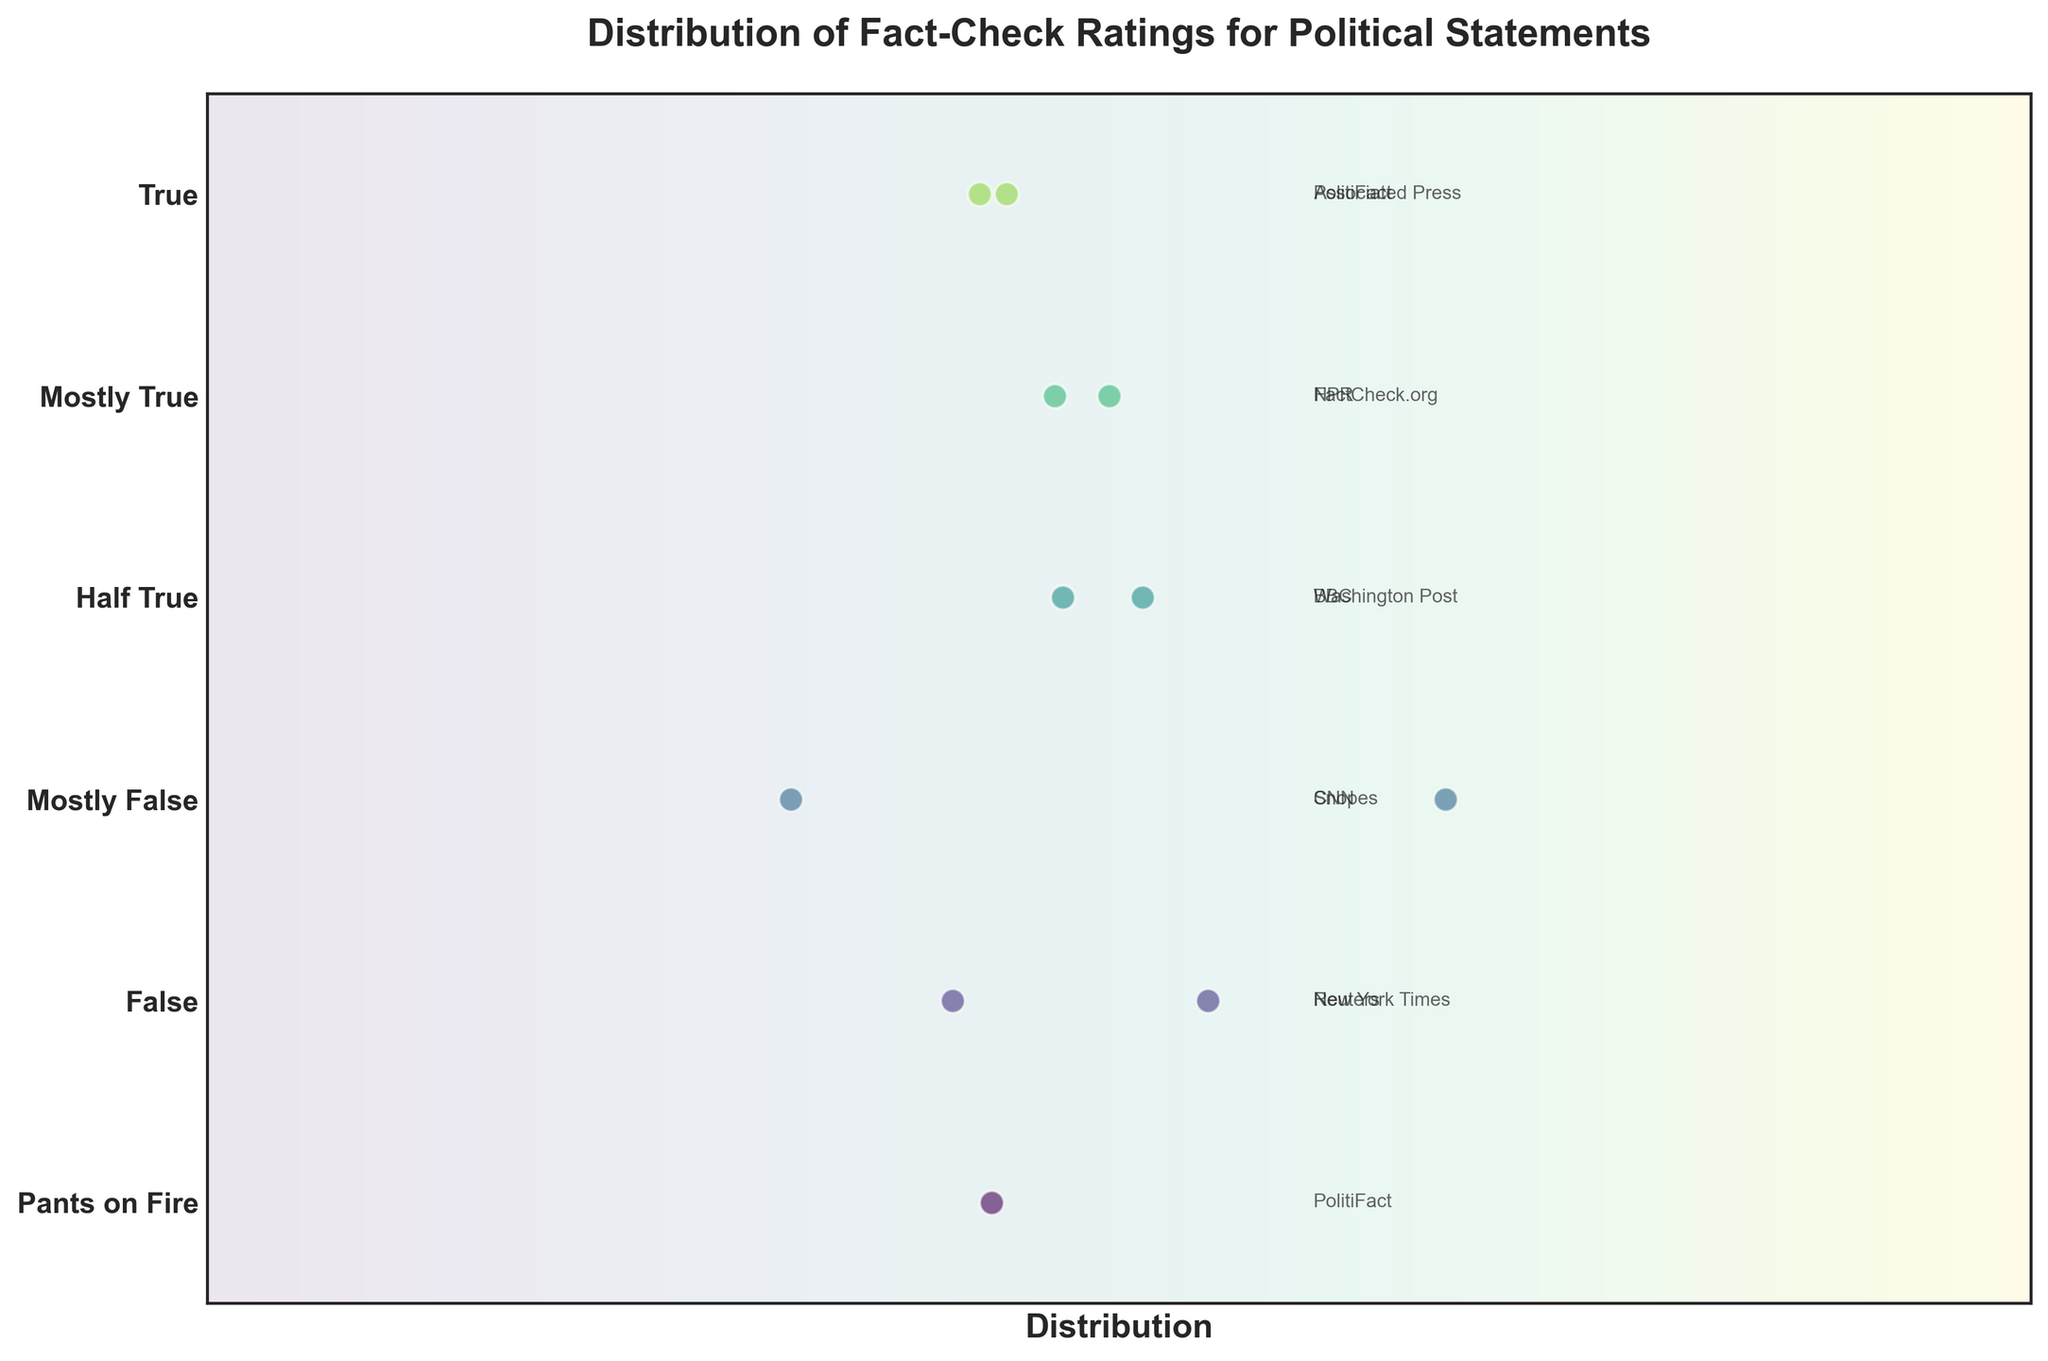What's the title of the figure? The title is usually found at the top of the figure. In this case, it reads "Distribution of Fact-Check Ratings for Political Statements".
Answer: Distribution of Fact-Check Ratings for Political Statements How many statements were rated as 'True'? Look at the strip plot for the 'True' rating and count the dots. The 'True' rating has two dots representing two statements.
Answer: 2 Which rating has the most data points? Count the number of dots in each rating category. The 'Half True' and 'Mostly True' sections have the same number, which is two. However, all ratings have either one or two points, so no single rating overwhelmingly has the most.
Answer: Half True, Mostly True What is the color gradient used for the background? The gradient starts light and transitions to a darker color vertically, representing a spectrum found in the 'viridis' color map used for visibility.
Answer: Viridis How many sources are represented in the data? Each unique source label in the figure corresponds to a different source. Counting these unique labels gives us the number of sources. There are 11 unique source labels: PolitiFact, FactCheck.org, Washington Post, Snopes, Reuters, Associated Press, NPR, BBC, CNN, New York Times.
Answer: 11 Which source made the statement rated 'Pants on Fire'? Look at the 'Pants on Fire' strip and identify the source label next to the dot. The source for the 'Pants on Fire' statement is PolitiFact.
Answer: PolitiFact Which statement was rated 'Mostly False'? Read the annotation next to the dot in the 'Mostly False' strip. Two ratings are 'Mostly False': "Unemployment is low because everyone has two jobs" by AOC and "We cut illegal immigration at the southern border by 90%" by Pence.
Answer: 2 Are there more statements rated 'False' or 'True'? Count the number of dots in the 'False' section and the 'True' section. There are two dots in each, so they are equal.
Answer: Equal Which statement has the most extreme rating, and what is that rating? The most extreme rating in this context is 'Pants on Fire'. The statement rated 'Pants on Fire' is "The California wildfires were caused by Jewish space lasers" by Greene.
Answer: "The California wildfires were caused by Jewish space lasers" by Greene 